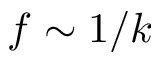<formula> <loc_0><loc_0><loc_500><loc_500>f \sim 1 / k</formula> 